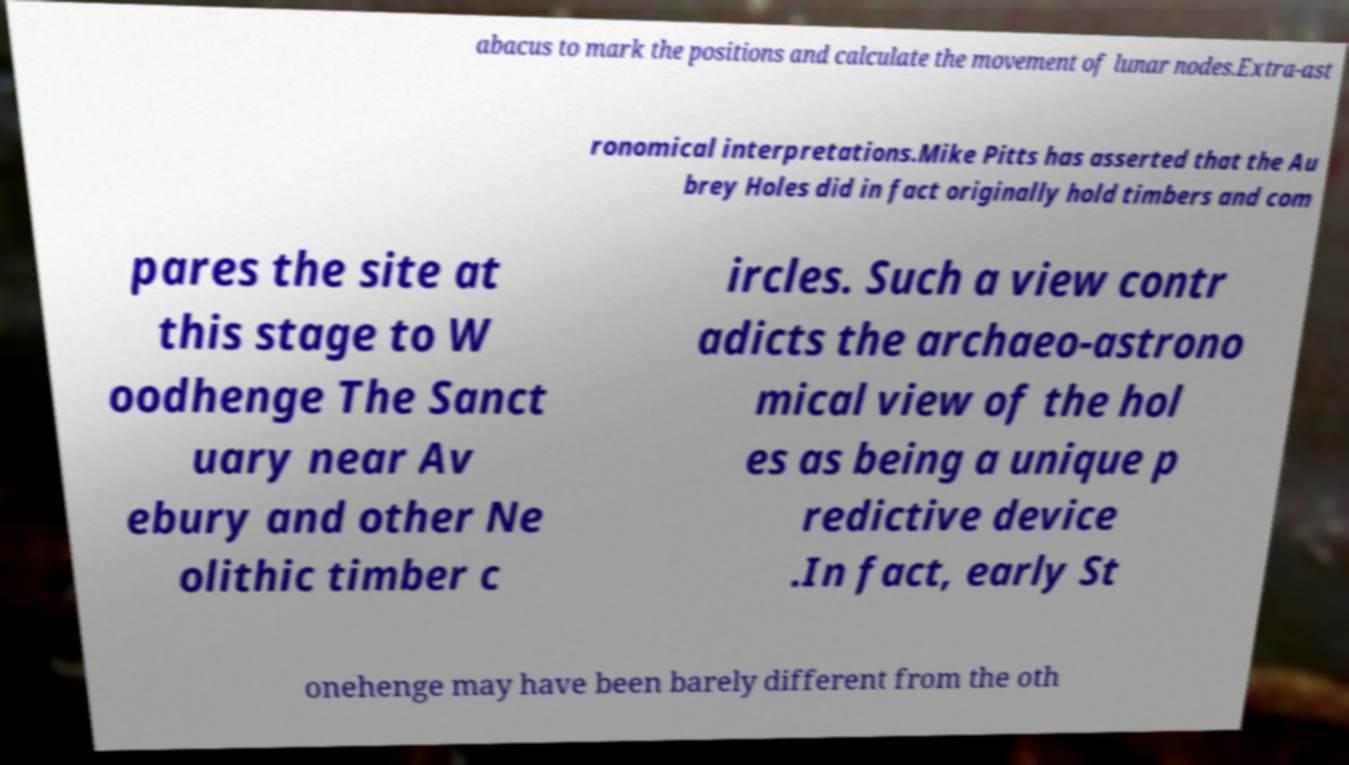For documentation purposes, I need the text within this image transcribed. Could you provide that? abacus to mark the positions and calculate the movement of lunar nodes.Extra-ast ronomical interpretations.Mike Pitts has asserted that the Au brey Holes did in fact originally hold timbers and com pares the site at this stage to W oodhenge The Sanct uary near Av ebury and other Ne olithic timber c ircles. Such a view contr adicts the archaeo-astrono mical view of the hol es as being a unique p redictive device .In fact, early St onehenge may have been barely different from the oth 